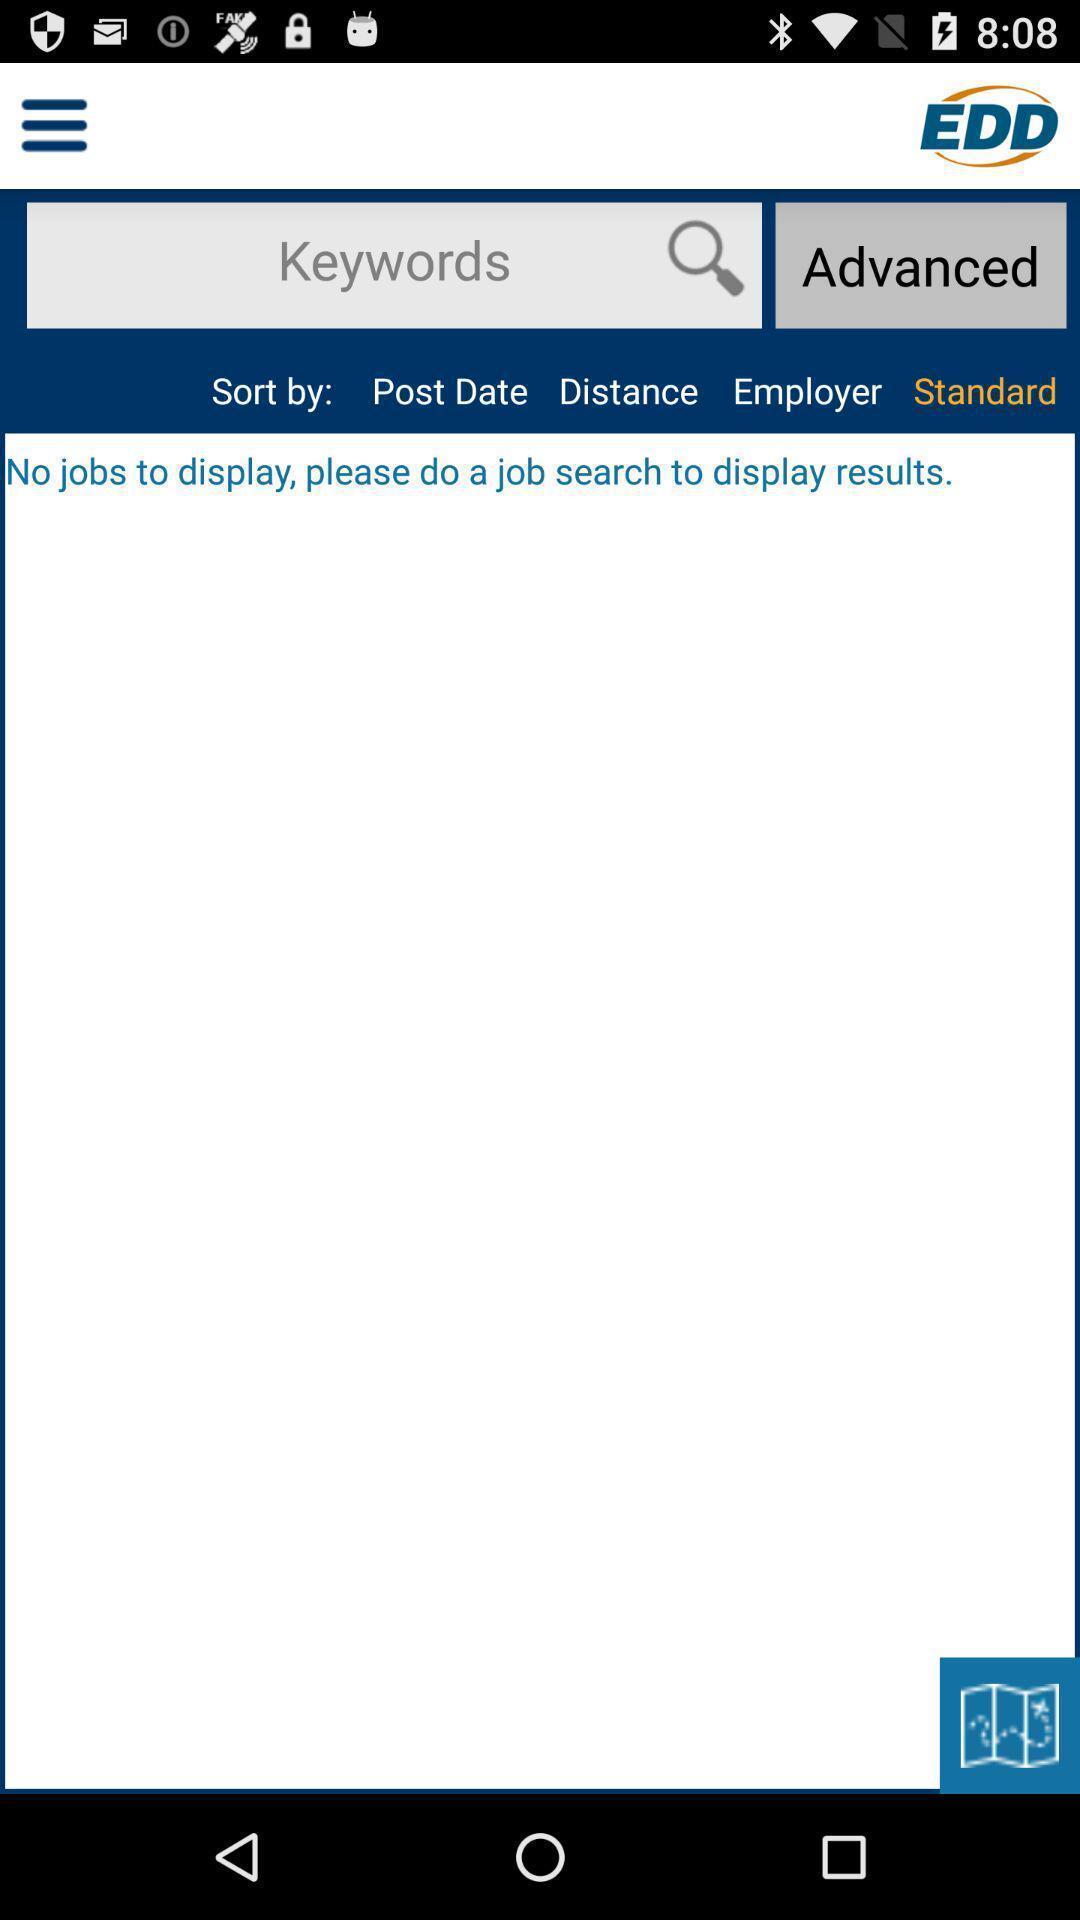Provide a textual representation of this image. Search bar to search for jobs in app. 